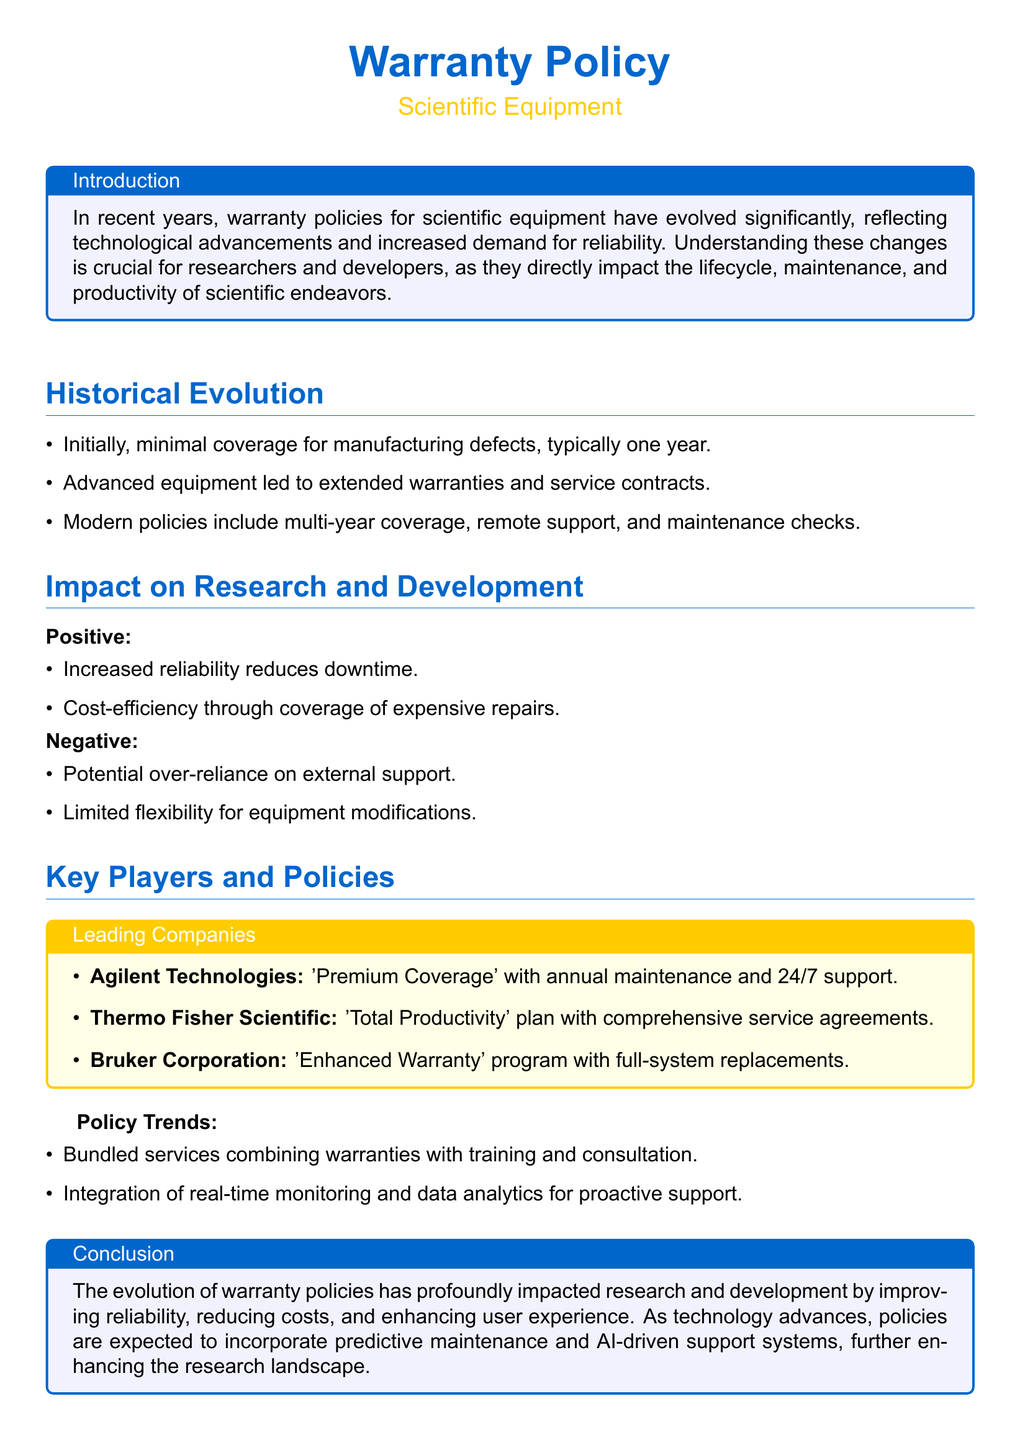What is the initial warranty coverage for manufacturing defects? The document states that initially, there was minimal coverage for manufacturing defects, typically one year.
Answer: one year What is the name of Agilent Technologies' warranty program? The document lists Agilent Technologies' warranty program as 'Premium Coverage' with annual maintenance and 24/7 support.
Answer: Premium Coverage What are two positive impacts of warranty policies on research and development? The document highlights increased reliability reduces downtime and cost-efficiency through coverage of expensive repairs as positive impacts.
Answer: increased reliability, cost-efficiency What is a potential negative effect of reliance on warranty policies? The document mentions that a negative effect could be potential over-reliance on external support.
Answer: over-reliance on external support Which company offers the 'Total Productivity' plan? The document indicates that Thermo Fisher Scientific offers the 'Total Productivity' plan with comprehensive service agreements.
Answer: Thermo Fisher Scientific What is a trend mentioned in policy development for scientific equipment warranties? The document notes that one trend is the integration of real-time monitoring and data analytics for proactive support.
Answer: integration of real-time monitoring What does the conclusion suggest about future warranty policies? The conclusion states that future policies are expected to incorporate predictive maintenance and AI-driven support systems.
Answer: predictive maintenance and AI-driven support systems 